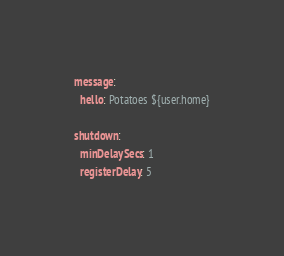<code> <loc_0><loc_0><loc_500><loc_500><_YAML_>message:
  hello: Potatoes ${user.home}

shutdown:
  minDelaySecs: 1
  registerDelay: 5
</code> 